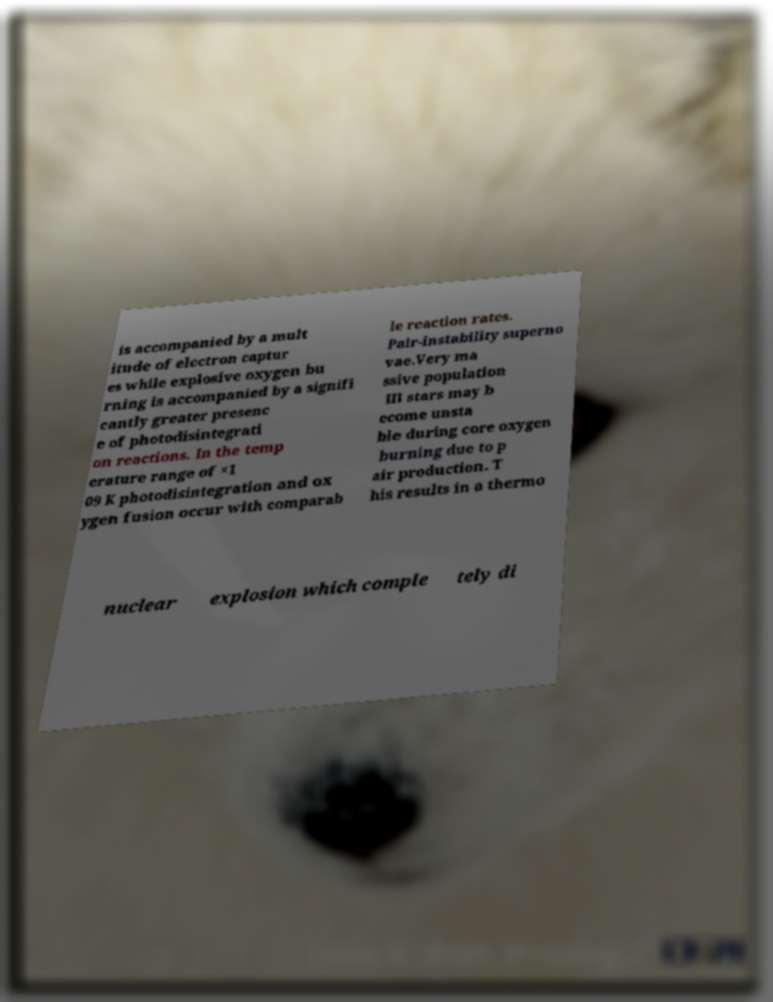For documentation purposes, I need the text within this image transcribed. Could you provide that? is accompanied by a mult itude of electron captur es while explosive oxygen bu rning is accompanied by a signifi cantly greater presenc e of photodisintegrati on reactions. In the temp erature range of ×1 09 K photodisintegration and ox ygen fusion occur with comparab le reaction rates. Pair-instability superno vae.Very ma ssive population III stars may b ecome unsta ble during core oxygen burning due to p air production. T his results in a thermo nuclear explosion which comple tely di 